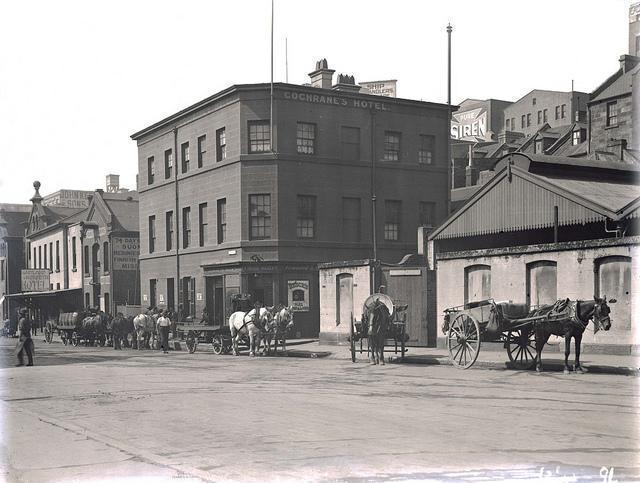How many horses are in the photo?
Give a very brief answer. 1. How many zebras are facing the camera?
Give a very brief answer. 0. 